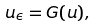<formula> <loc_0><loc_0><loc_500><loc_500>u _ { \epsilon } = G ( u ) ,</formula> 